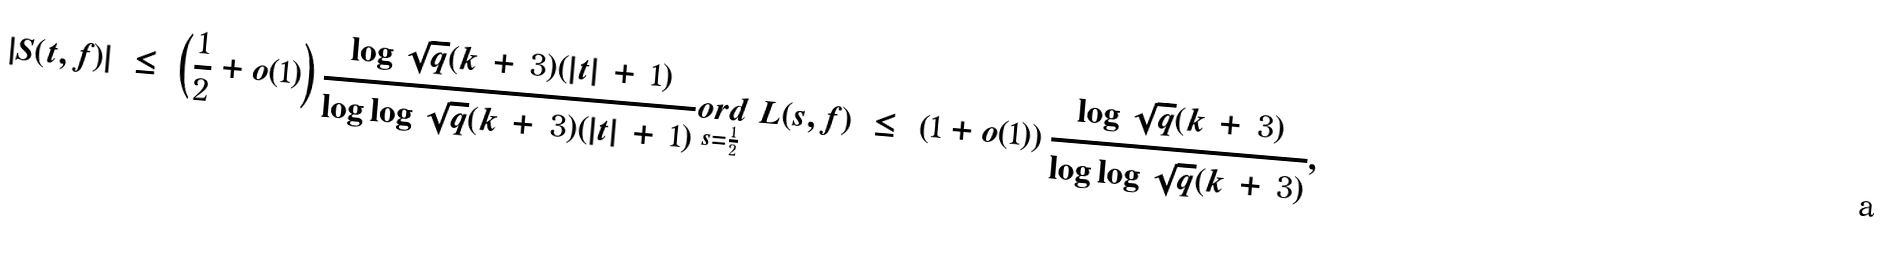<formula> <loc_0><loc_0><loc_500><loc_500>| S ( t , f ) | \ \leq \ \left ( \frac { 1 } { 2 } + o ( 1 ) \right ) \frac { \log \sqrt { q } ( k \, + \, 3 ) ( | t | \, + \, 1 ) } { \log \log \sqrt { q } ( k \, + \, 3 ) ( | t | \, + \, 1 ) } \underset { s = \frac { 1 } { 2 } } { o r d } \ L ( s , f ) \ \leq \ \left ( 1 + o ( 1 ) \right ) \frac { \log \sqrt { q } ( k \, + \, 3 ) } { \log \log \sqrt { q } ( k \, + \, 3 ) } ,</formula> 